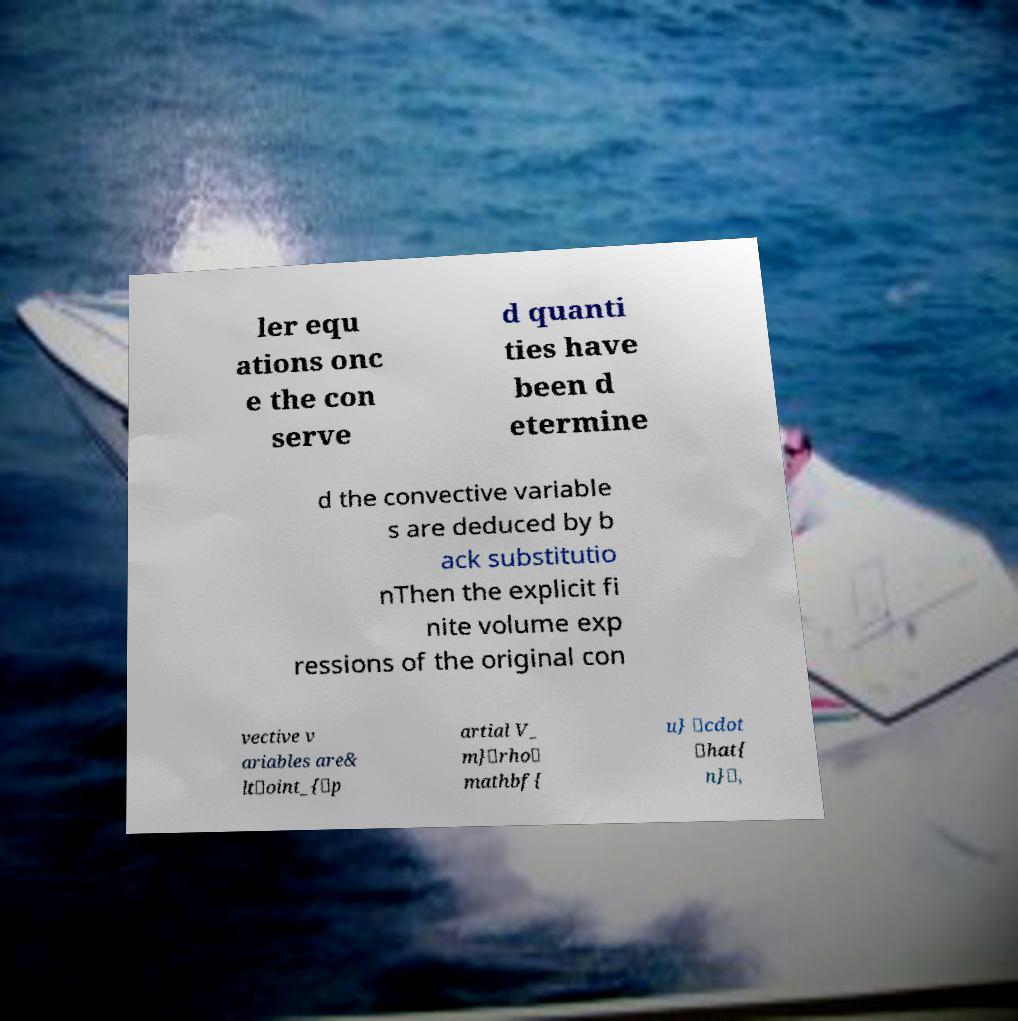There's text embedded in this image that I need extracted. Can you transcribe it verbatim? ler equ ations onc e the con serve d quanti ties have been d etermine d the convective variable s are deduced by b ack substitutio nThen the explicit fi nite volume exp ressions of the original con vective v ariables are& lt\oint_{\p artial V_ m}\rho\ mathbf{ u} \cdot \hat{ n}\, 